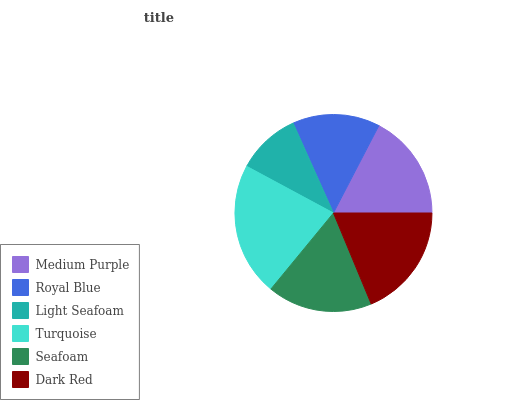Is Light Seafoam the minimum?
Answer yes or no. Yes. Is Turquoise the maximum?
Answer yes or no. Yes. Is Royal Blue the minimum?
Answer yes or no. No. Is Royal Blue the maximum?
Answer yes or no. No. Is Medium Purple greater than Royal Blue?
Answer yes or no. Yes. Is Royal Blue less than Medium Purple?
Answer yes or no. Yes. Is Royal Blue greater than Medium Purple?
Answer yes or no. No. Is Medium Purple less than Royal Blue?
Answer yes or no. No. Is Medium Purple the high median?
Answer yes or no. Yes. Is Seafoam the low median?
Answer yes or no. Yes. Is Seafoam the high median?
Answer yes or no. No. Is Medium Purple the low median?
Answer yes or no. No. 